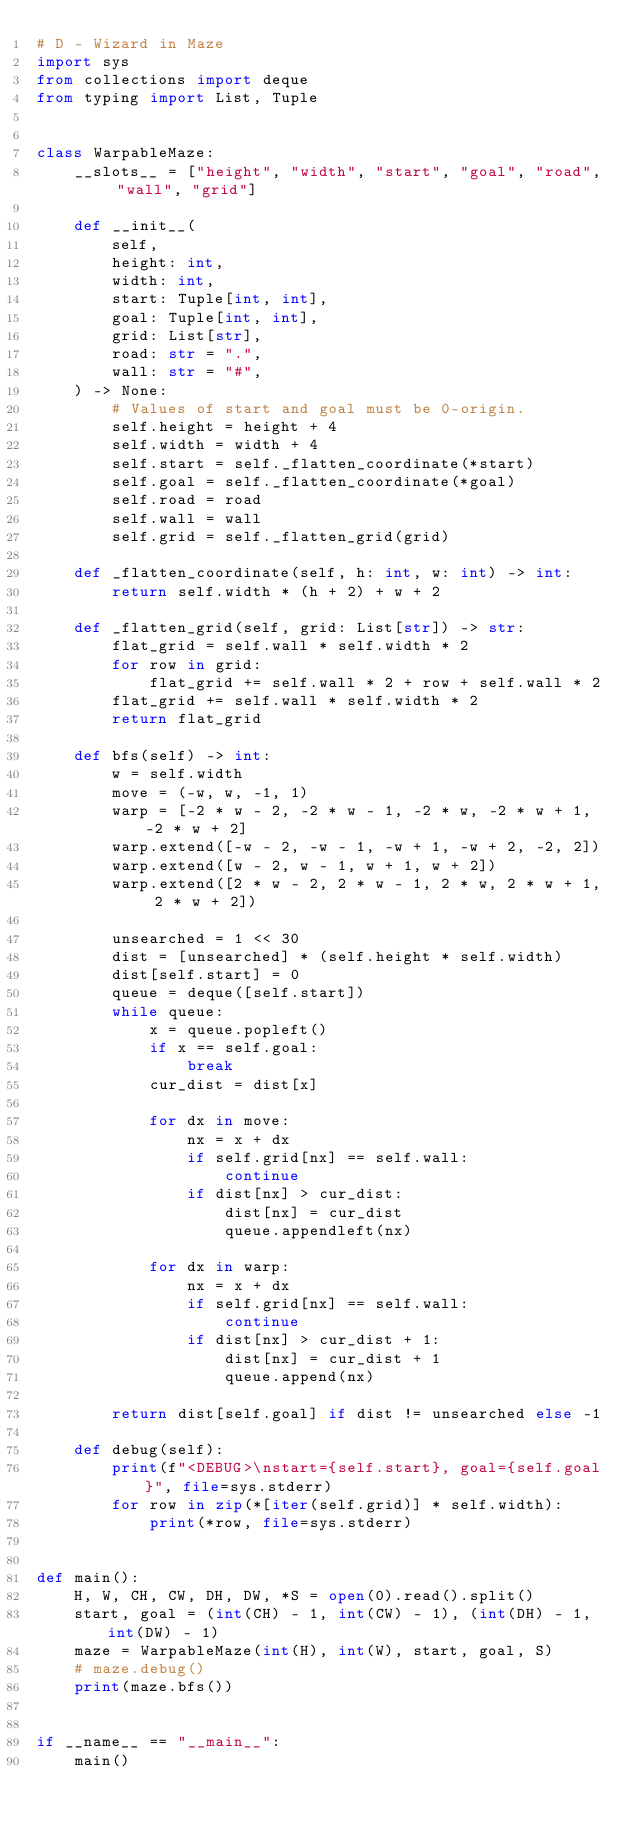Convert code to text. <code><loc_0><loc_0><loc_500><loc_500><_Python_># D - Wizard in Maze
import sys
from collections import deque
from typing import List, Tuple


class WarpableMaze:
    __slots__ = ["height", "width", "start", "goal", "road", "wall", "grid"]

    def __init__(
        self,
        height: int,
        width: int,
        start: Tuple[int, int],
        goal: Tuple[int, int],
        grid: List[str],
        road: str = ".",
        wall: str = "#",
    ) -> None:
        # Values of start and goal must be 0-origin.
        self.height = height + 4
        self.width = width + 4
        self.start = self._flatten_coordinate(*start)
        self.goal = self._flatten_coordinate(*goal)
        self.road = road
        self.wall = wall
        self.grid = self._flatten_grid(grid)

    def _flatten_coordinate(self, h: int, w: int) -> int:
        return self.width * (h + 2) + w + 2

    def _flatten_grid(self, grid: List[str]) -> str:
        flat_grid = self.wall * self.width * 2
        for row in grid:
            flat_grid += self.wall * 2 + row + self.wall * 2
        flat_grid += self.wall * self.width * 2
        return flat_grid

    def bfs(self) -> int:
        w = self.width
        move = (-w, w, -1, 1)
        warp = [-2 * w - 2, -2 * w - 1, -2 * w, -2 * w + 1, -2 * w + 2]
        warp.extend([-w - 2, -w - 1, -w + 1, -w + 2, -2, 2])
        warp.extend([w - 2, w - 1, w + 1, w + 2])
        warp.extend([2 * w - 2, 2 * w - 1, 2 * w, 2 * w + 1, 2 * w + 2])

        unsearched = 1 << 30
        dist = [unsearched] * (self.height * self.width)
        dist[self.start] = 0
        queue = deque([self.start])
        while queue:
            x = queue.popleft()
            if x == self.goal:
                break
            cur_dist = dist[x]

            for dx in move:
                nx = x + dx
                if self.grid[nx] == self.wall:
                    continue
                if dist[nx] > cur_dist:
                    dist[nx] = cur_dist
                    queue.appendleft(nx)

            for dx in warp:
                nx = x + dx
                if self.grid[nx] == self.wall:
                    continue
                if dist[nx] > cur_dist + 1:
                    dist[nx] = cur_dist + 1
                    queue.append(nx)

        return dist[self.goal] if dist != unsearched else -1

    def debug(self):
        print(f"<DEBUG>\nstart={self.start}, goal={self.goal}", file=sys.stderr)
        for row in zip(*[iter(self.grid)] * self.width):
            print(*row, file=sys.stderr)


def main():
    H, W, CH, CW, DH, DW, *S = open(0).read().split()
    start, goal = (int(CH) - 1, int(CW) - 1), (int(DH) - 1, int(DW) - 1)
    maze = WarpableMaze(int(H), int(W), start, goal, S)
    # maze.debug()
    print(maze.bfs())


if __name__ == "__main__":
    main()
</code> 